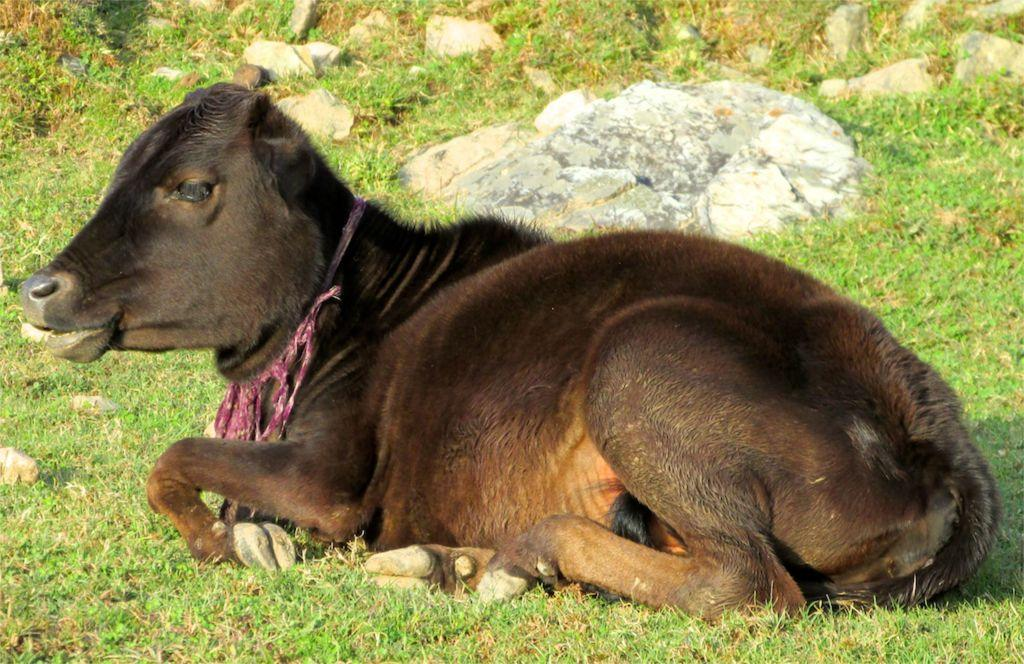What type of animal can be seen in the image? There is an animal in the image, but its specific type cannot be determined from the provided facts. Where is the animal located in the image? The animal is on the ground in the image. What can be seen in the background of the image? There is grass and stones in the background of the image. What color is the vest worn by the animal in the image? There is no vest present in the image, and therefore no color can be determined. 